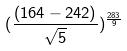Convert formula to latex. <formula><loc_0><loc_0><loc_500><loc_500>( \frac { ( 1 6 4 - 2 4 2 ) } { \sqrt { 5 } } ) ^ { \frac { 2 8 3 } { 9 } }</formula> 